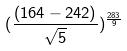Convert formula to latex. <formula><loc_0><loc_0><loc_500><loc_500>( \frac { ( 1 6 4 - 2 4 2 ) } { \sqrt { 5 } } ) ^ { \frac { 2 8 3 } { 9 } }</formula> 